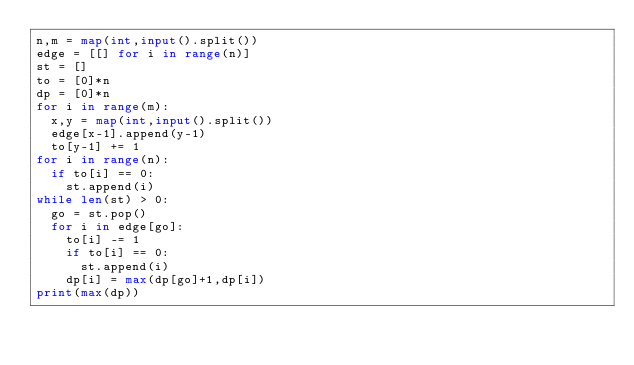<code> <loc_0><loc_0><loc_500><loc_500><_Python_>n,m = map(int,input().split())
edge = [[] for i in range(n)]
st = []
to = [0]*n
dp = [0]*n
for i in range(m):
  x,y = map(int,input().split())
  edge[x-1].append(y-1)
  to[y-1] += 1
for i in range(n):
  if to[i] == 0:
    st.append(i)
while len(st) > 0:
  go = st.pop()
  for i in edge[go]:
    to[i] -= 1
    if to[i] == 0:
      st.append(i)
    dp[i] = max(dp[go]+1,dp[i])
print(max(dp))</code> 